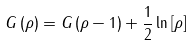<formula> <loc_0><loc_0><loc_500><loc_500>G \left ( \rho \right ) = G \left ( \rho - 1 \right ) + \frac { 1 } { 2 } \ln \left [ \rho \right ]</formula> 